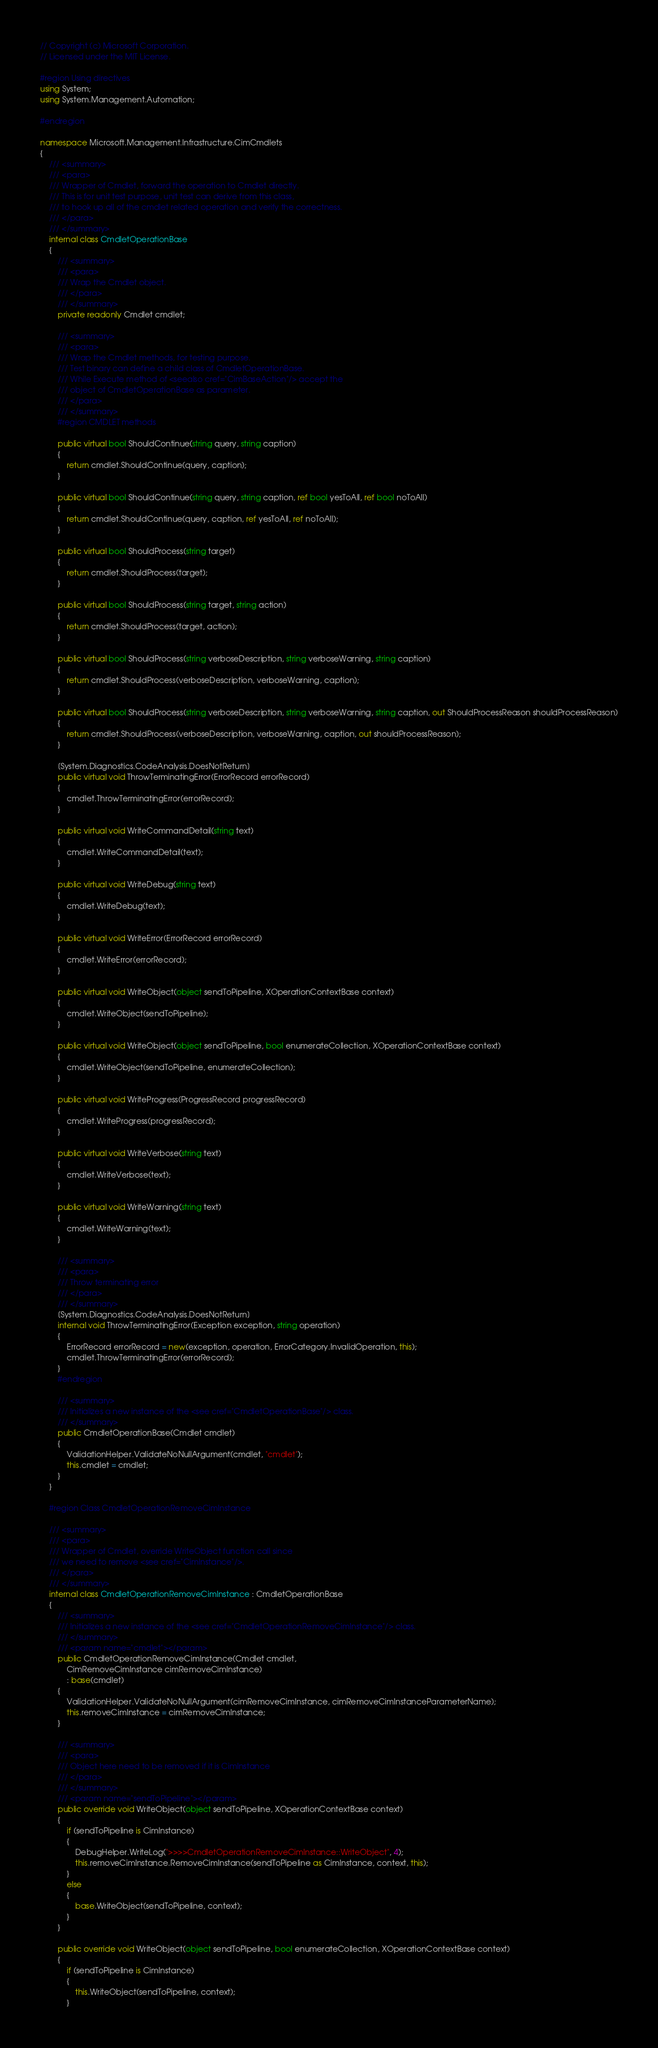Convert code to text. <code><loc_0><loc_0><loc_500><loc_500><_C#_>// Copyright (c) Microsoft Corporation.
// Licensed under the MIT License.

#region Using directives
using System;
using System.Management.Automation;

#endregion

namespace Microsoft.Management.Infrastructure.CimCmdlets
{
    /// <summary>
    /// <para>
    /// Wrapper of Cmdlet, forward the operation to Cmdlet directly.
    /// This is for unit test purpose, unit test can derive from this class,
    /// to hook up all of the cmdlet related operation and verify the correctness.
    /// </para>
    /// </summary>
    internal class CmdletOperationBase
    {
        /// <summary>
        /// <para>
        /// Wrap the Cmdlet object.
        /// </para>
        /// </summary>
        private readonly Cmdlet cmdlet;

        /// <summary>
        /// <para>
        /// Wrap the Cmdlet methods, for testing purpose.
        /// Test binary can define a child class of CmdletOperationBase.
        /// While Execute method of <seealso cref="CimBaseAction"/> accept the
        /// object of CmdletOperationBase as parameter.
        /// </para>
        /// </summary>
        #region CMDLET methods

        public virtual bool ShouldContinue(string query, string caption)
        {
            return cmdlet.ShouldContinue(query, caption);
        }

        public virtual bool ShouldContinue(string query, string caption, ref bool yesToAll, ref bool noToAll)
        {
            return cmdlet.ShouldContinue(query, caption, ref yesToAll, ref noToAll);
        }

        public virtual bool ShouldProcess(string target)
        {
            return cmdlet.ShouldProcess(target);
        }

        public virtual bool ShouldProcess(string target, string action)
        {
            return cmdlet.ShouldProcess(target, action);
        }

        public virtual bool ShouldProcess(string verboseDescription, string verboseWarning, string caption)
        {
            return cmdlet.ShouldProcess(verboseDescription, verboseWarning, caption);
        }

        public virtual bool ShouldProcess(string verboseDescription, string verboseWarning, string caption, out ShouldProcessReason shouldProcessReason)
        {
            return cmdlet.ShouldProcess(verboseDescription, verboseWarning, caption, out shouldProcessReason);
        }

        [System.Diagnostics.CodeAnalysis.DoesNotReturn]
        public virtual void ThrowTerminatingError(ErrorRecord errorRecord)
        {
            cmdlet.ThrowTerminatingError(errorRecord);
        }

        public virtual void WriteCommandDetail(string text)
        {
            cmdlet.WriteCommandDetail(text);
        }

        public virtual void WriteDebug(string text)
        {
            cmdlet.WriteDebug(text);
        }

        public virtual void WriteError(ErrorRecord errorRecord)
        {
            cmdlet.WriteError(errorRecord);
        }

        public virtual void WriteObject(object sendToPipeline, XOperationContextBase context)
        {
            cmdlet.WriteObject(sendToPipeline);
        }

        public virtual void WriteObject(object sendToPipeline, bool enumerateCollection, XOperationContextBase context)
        {
            cmdlet.WriteObject(sendToPipeline, enumerateCollection);
        }

        public virtual void WriteProgress(ProgressRecord progressRecord)
        {
            cmdlet.WriteProgress(progressRecord);
        }

        public virtual void WriteVerbose(string text)
        {
            cmdlet.WriteVerbose(text);
        }

        public virtual void WriteWarning(string text)
        {
            cmdlet.WriteWarning(text);
        }

        /// <summary>
        /// <para>
        /// Throw terminating error
        /// </para>
        /// </summary>
        [System.Diagnostics.CodeAnalysis.DoesNotReturn]
        internal void ThrowTerminatingError(Exception exception, string operation)
        {
            ErrorRecord errorRecord = new(exception, operation, ErrorCategory.InvalidOperation, this);
            cmdlet.ThrowTerminatingError(errorRecord);
        }
        #endregion

        /// <summary>
        /// Initializes a new instance of the <see cref="CmdletOperationBase"/> class.
        /// </summary>
        public CmdletOperationBase(Cmdlet cmdlet)
        {
            ValidationHelper.ValidateNoNullArgument(cmdlet, "cmdlet");
            this.cmdlet = cmdlet;
        }
    }

    #region Class CmdletOperationRemoveCimInstance

    /// <summary>
    /// <para>
    /// Wrapper of Cmdlet, override WriteObject function call since
    /// we need to remove <see cref="CimInstance"/>.
    /// </para>
    /// </summary>
    internal class CmdletOperationRemoveCimInstance : CmdletOperationBase
    {
        /// <summary>
        /// Initializes a new instance of the <see cref="CmdletOperationRemoveCimInstance"/> class.
        /// </summary>
        /// <param name="cmdlet"></param>
        public CmdletOperationRemoveCimInstance(Cmdlet cmdlet,
            CimRemoveCimInstance cimRemoveCimInstance)
            : base(cmdlet)
        {
            ValidationHelper.ValidateNoNullArgument(cimRemoveCimInstance, cimRemoveCimInstanceParameterName);
            this.removeCimInstance = cimRemoveCimInstance;
        }

        /// <summary>
        /// <para>
        /// Object here need to be removed if it is CimInstance
        /// </para>
        /// </summary>
        /// <param name="sendToPipeline"></param>
        public override void WriteObject(object sendToPipeline, XOperationContextBase context)
        {
            if (sendToPipeline is CimInstance)
            {
                DebugHelper.WriteLog(">>>>CmdletOperationRemoveCimInstance::WriteObject", 4);
                this.removeCimInstance.RemoveCimInstance(sendToPipeline as CimInstance, context, this);
            }
            else
            {
                base.WriteObject(sendToPipeline, context);
            }
        }

        public override void WriteObject(object sendToPipeline, bool enumerateCollection, XOperationContextBase context)
        {
            if (sendToPipeline is CimInstance)
            {
                this.WriteObject(sendToPipeline, context);
            }</code> 